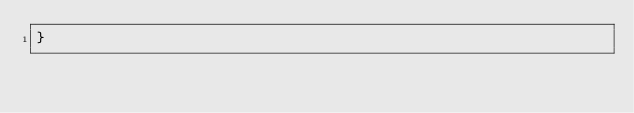Convert code to text. <code><loc_0><loc_0><loc_500><loc_500><_Awk_>}
</code> 